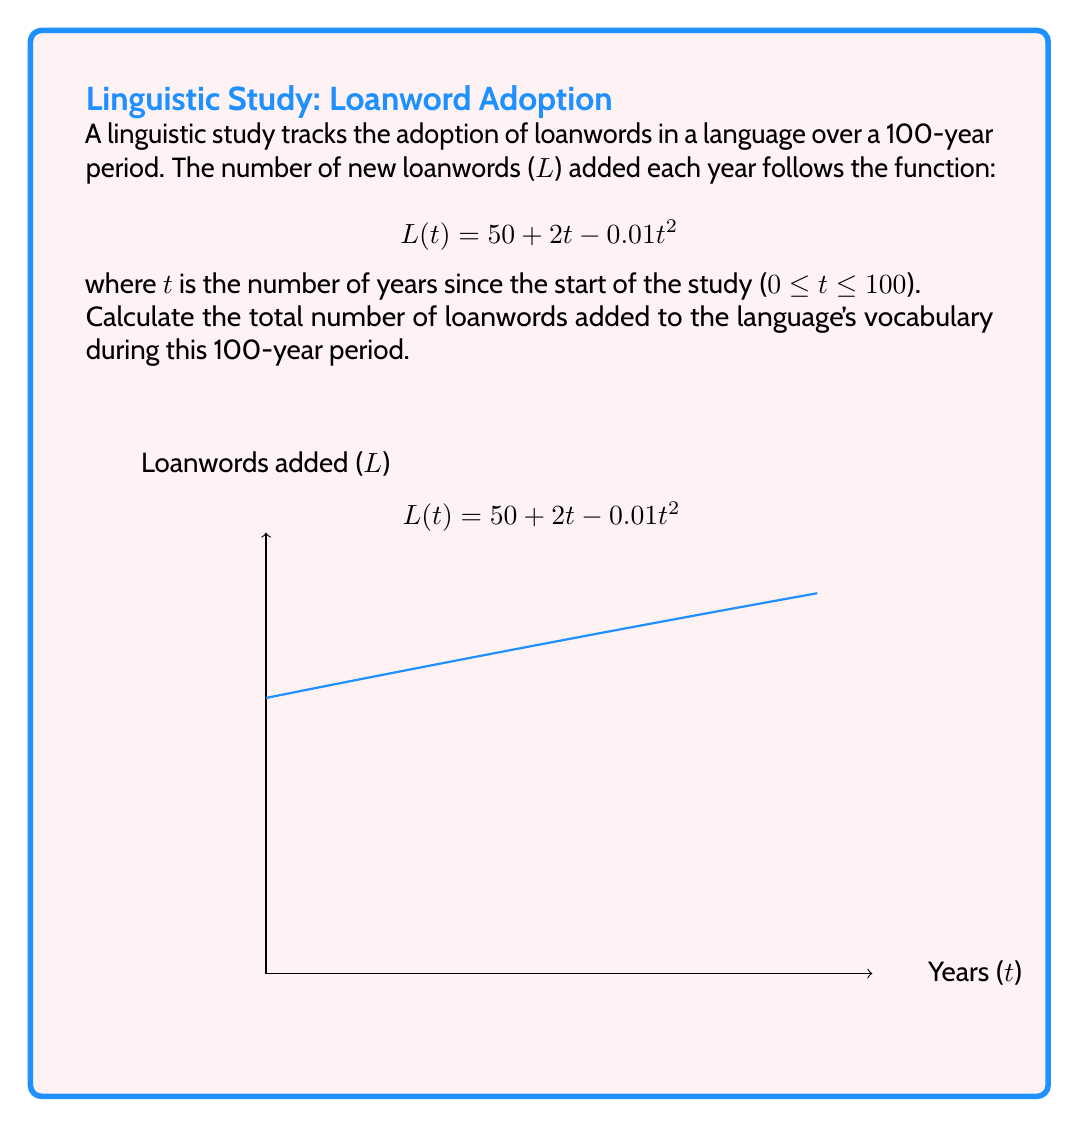Help me with this question. To find the total number of loanwords added over the 100-year period, we need to calculate the definite integral of the function L(t) from t = 0 to t = 100.

Step 1: Set up the definite integral
$$\int_{0}^{100} (50 + 2t - 0.01t^2) dt$$

Step 2: Integrate the function
$$\left[50t + t^2 - \frac{0.01t^3}{3}\right]_{0}^{100}$$

Step 3: Evaluate the integral at the upper and lower bounds
Upper bound (t = 100):
$$50(100) + 100^2 - \frac{0.01(100^3)}{3} = 5000 + 10000 - 3333.33 = 11666.67$$

Lower bound (t = 0):
$$50(0) + 0^2 - \frac{0.01(0^3)}{3} = 0$$

Step 4: Subtract the lower bound from the upper bound
$$11666.67 - 0 = 11666.67$$

Step 5: Round to the nearest whole number, as we can't have a fractional number of words
$$11666.67 \approx 11667$$

Therefore, the total number of loanwords added to the language's vocabulary during the 100-year period is approximately 11,667.
Answer: 11,667 loanwords 